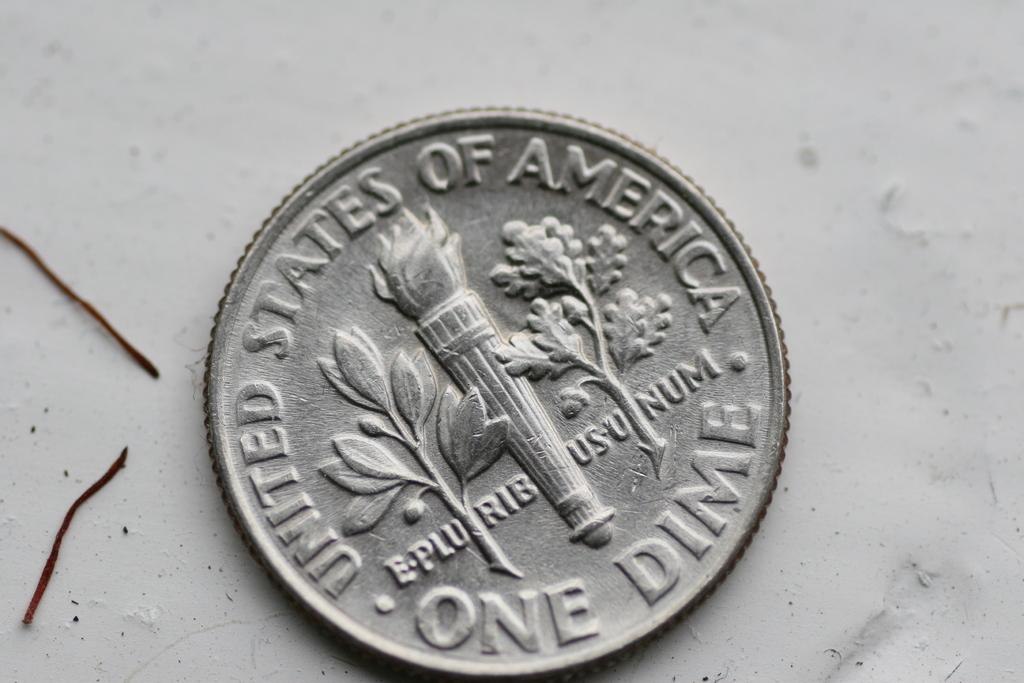<image>
Give a short and clear explanation of the subsequent image. A United States of America one dime coin on a white surface. 